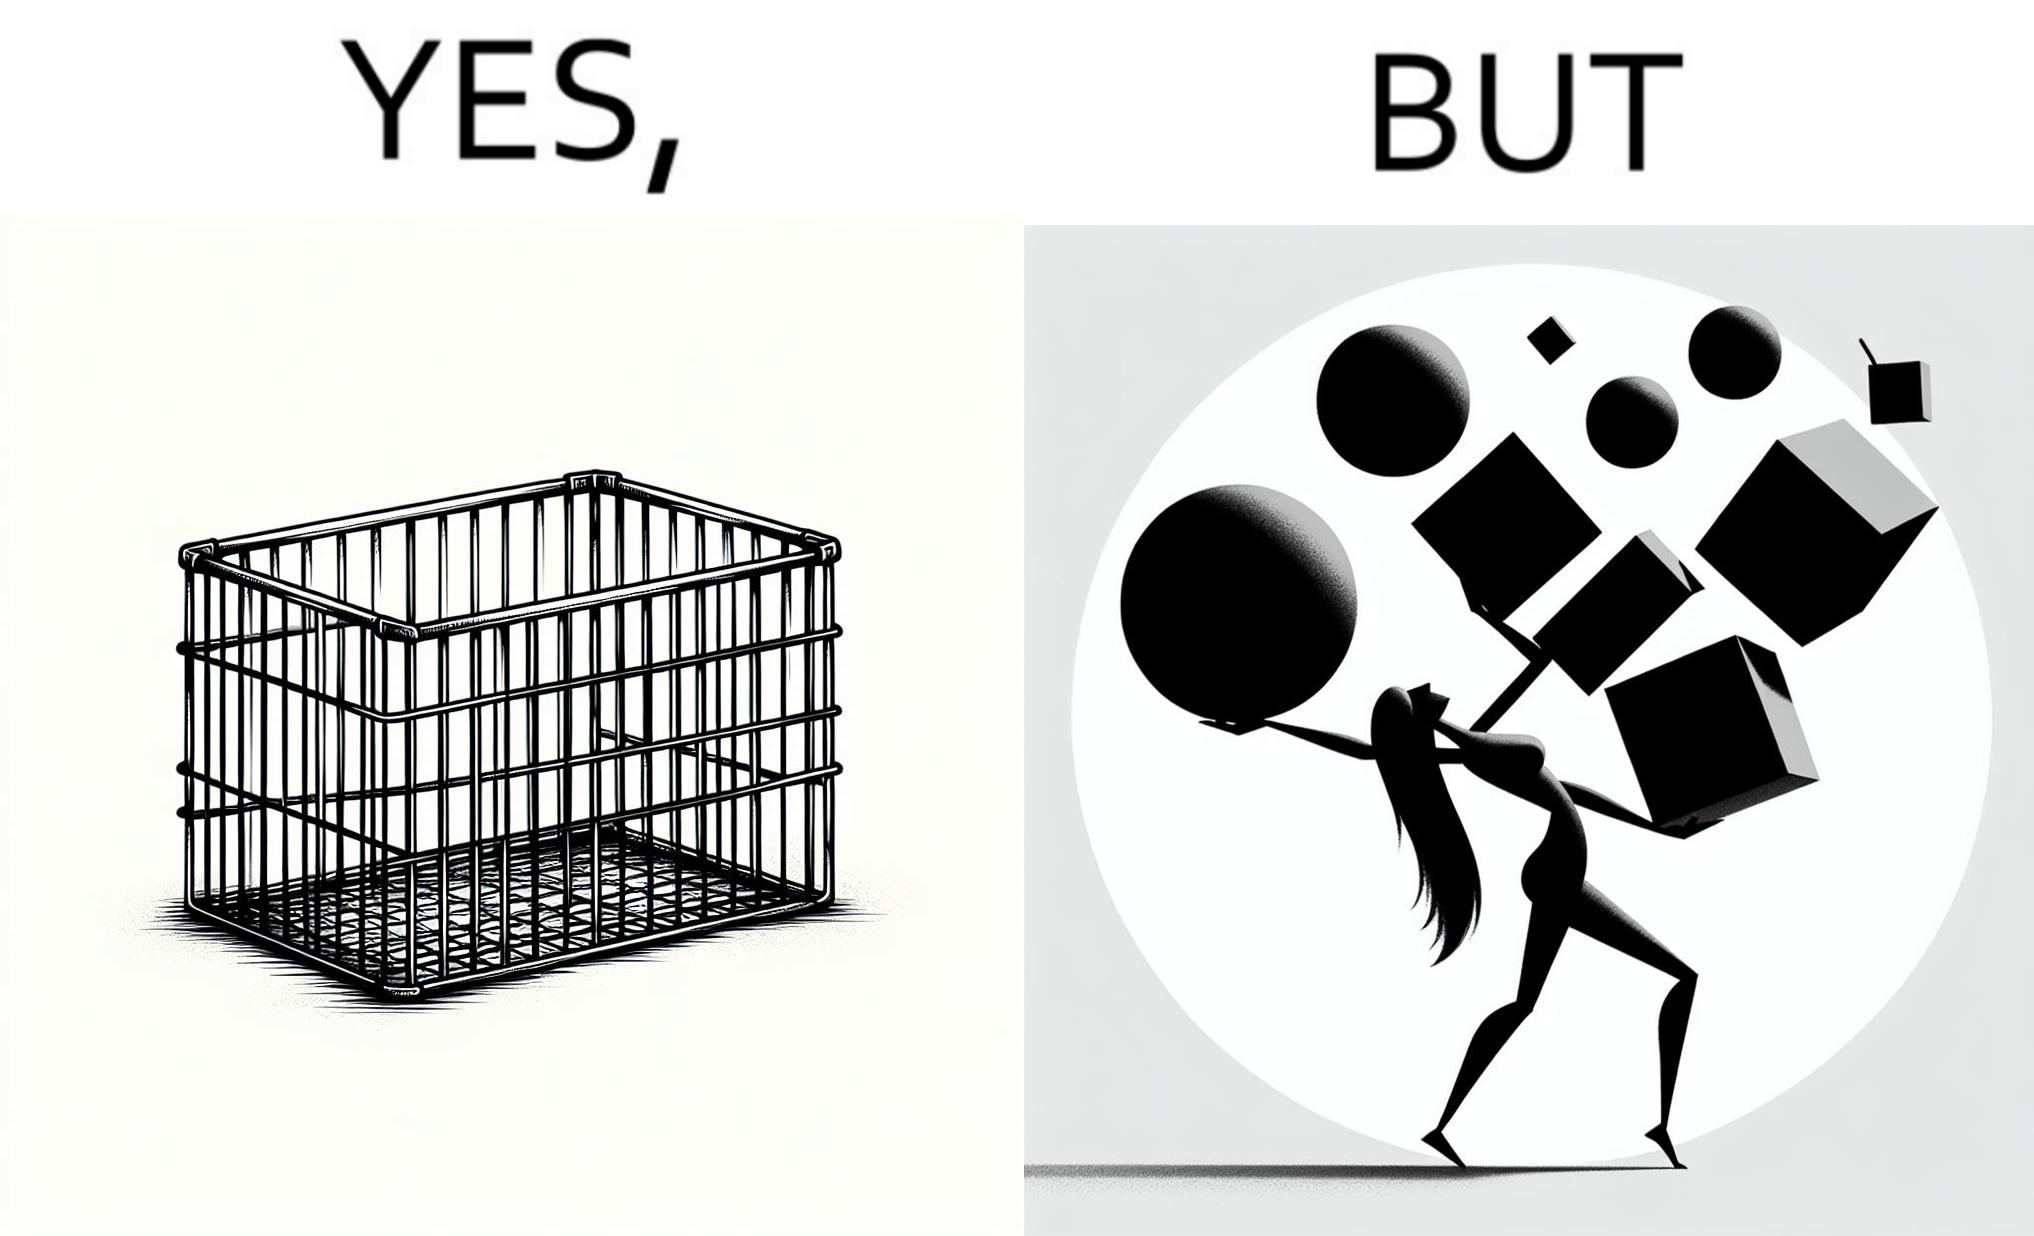Explain the humor or irony in this image. The image is ironic, because even when there are steel frame baskets are available at the supermarkets people prefer carrying the items in hand 